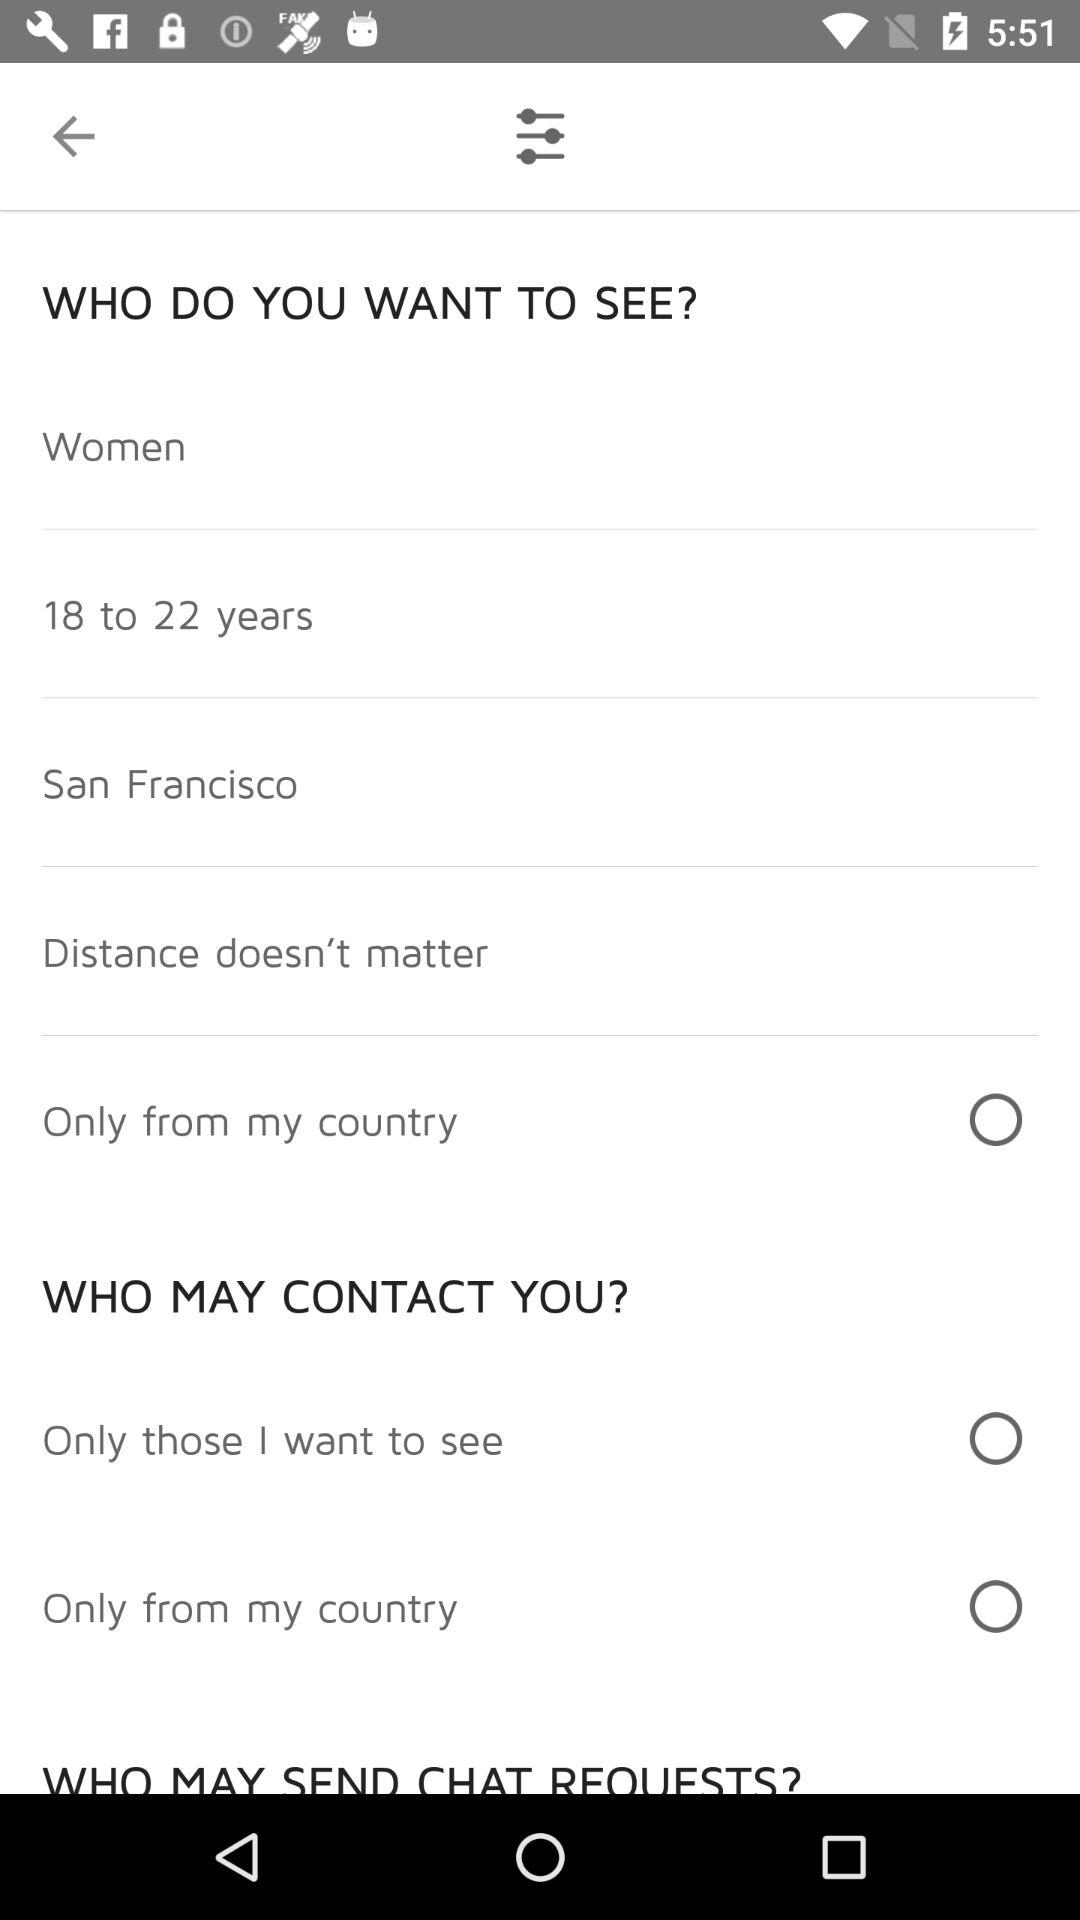What is the required age? The required age range is 18 to 22 years. 